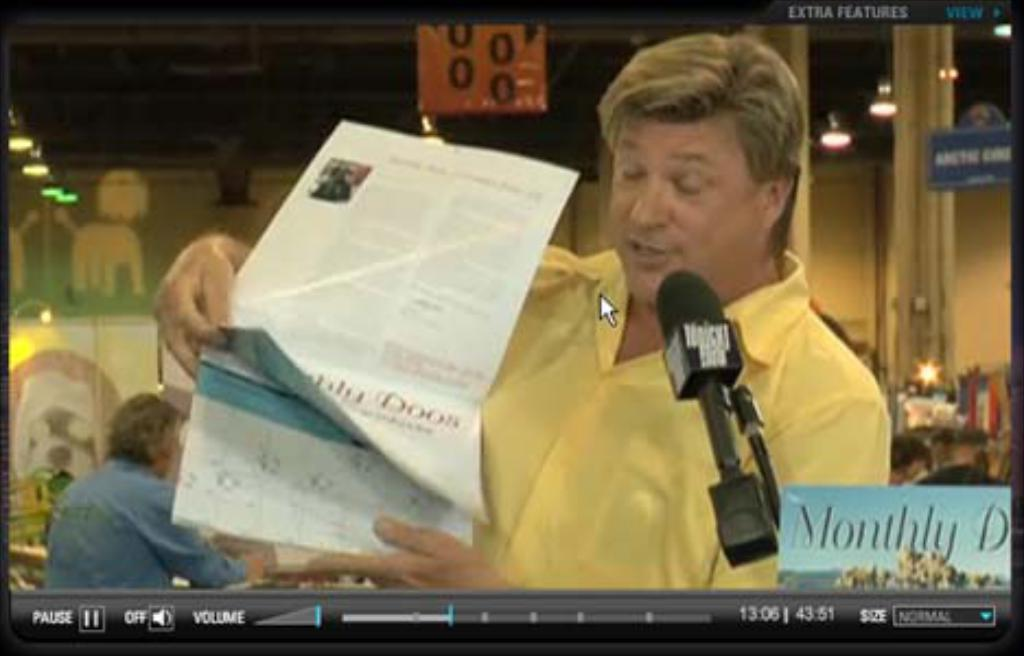What can be seen on the video screen in the image? The content of the video screen cannot be determined from the provided facts. What is the first man doing in the image? The first man is sitting in front of the video screen and holding a newspaper. Can you describe the position of the second man in the image? The second man is sitting behind the first man. What type of lighting is present in the image? Lights are visible on the ceiling. What architectural feature can be seen in the image? There is a pillar in the image. What type of watch is the first man wearing in the image? There is no mention of a watch in the provided facts, so it cannot be determined if the first man is wearing a watch or not. 